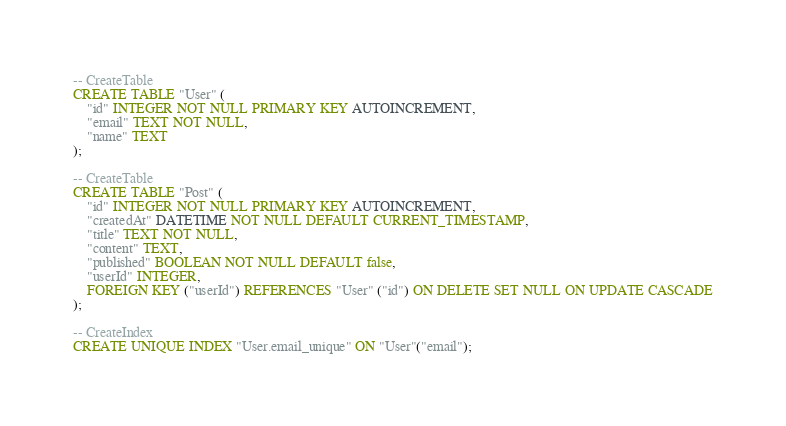<code> <loc_0><loc_0><loc_500><loc_500><_SQL_>-- CreateTable
CREATE TABLE "User" (
    "id" INTEGER NOT NULL PRIMARY KEY AUTOINCREMENT,
    "email" TEXT NOT NULL,
    "name" TEXT
);

-- CreateTable
CREATE TABLE "Post" (
    "id" INTEGER NOT NULL PRIMARY KEY AUTOINCREMENT,
    "createdAt" DATETIME NOT NULL DEFAULT CURRENT_TIMESTAMP,
    "title" TEXT NOT NULL,
    "content" TEXT,
    "published" BOOLEAN NOT NULL DEFAULT false,
    "userId" INTEGER,
    FOREIGN KEY ("userId") REFERENCES "User" ("id") ON DELETE SET NULL ON UPDATE CASCADE
);

-- CreateIndex
CREATE UNIQUE INDEX "User.email_unique" ON "User"("email");
</code> 